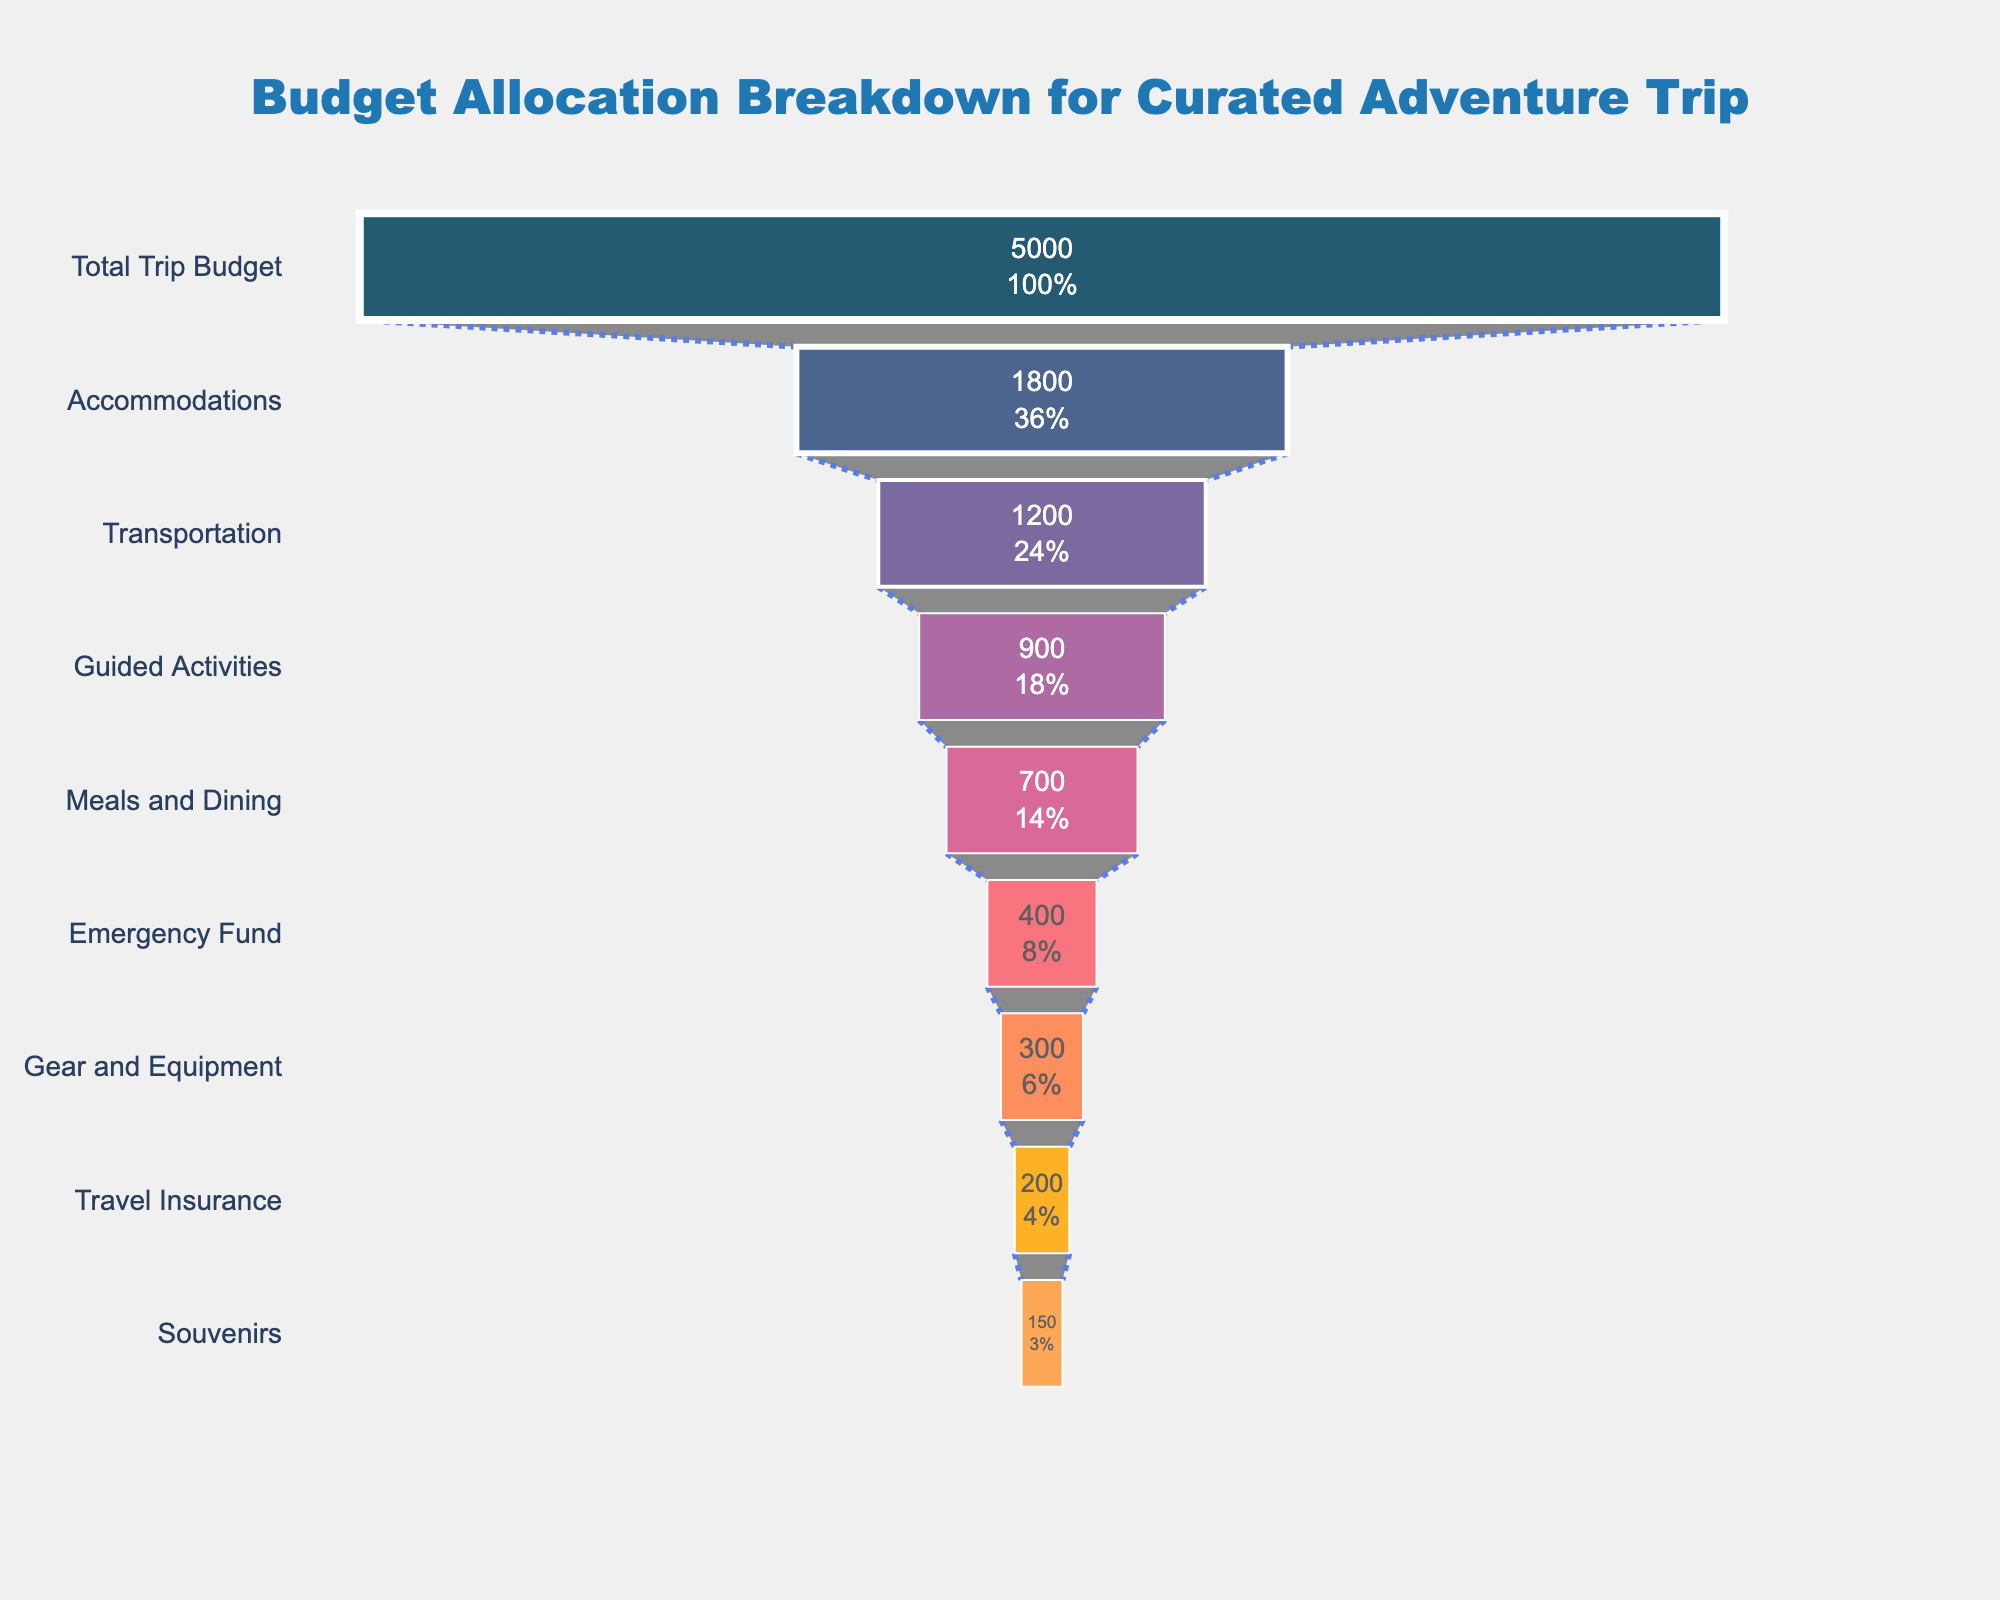What is the total budget for the trip as depicted in the figure? The total budget for the trip is the topmost stage in the funnel, labeled "Total Trip Budget," which shows an allocation of $5000.
Answer: $5000 Which aspect has the highest budget allocation after accommodations? The second highest budget allocation after accommodations is for transportation, as it is the next stage in the funnel with $1200 allocated.
Answer: Transportation How much more is allocated to accommodations compared to meals and dining? The amount allocated to accommodations is $1800 and meals and dining is $700. The difference is $1800 - $700 = $1100.
Answer: $1100 Which aspect has the lowest budget allocation? The lowest budget allocation is for souvenirs, as depicted at the bottom of the funnel with $150 allocated.
Answer: Souvenirs What percentage of the total budget is allocated to guided activities? Guided activities have a budget of $900. To find the percentage of the total budget, we use the formula (900 / 5000) * 100%, which equals 18%.
Answer: 18% Compare the combined budget of emergency fund and gear and equipment to the budget for accommodations. The emergency fund is $400 and gear and equipment is $300, combined they total $700. Accommodations have a budget of $1800, so $1800 - $700 = $1100 more for accommodations.
Answer: $1100 more for accommodations What is the proportion of the total budget allocated to travel insurance? Travel insurance has a budget of $200. To find the proportion, divide $200 by the total budget $5000, yielding 200/5000 = 0.04 or 4%.
Answer: 4% Which two aspects have nearly identical budget allocations, and what are their values? Gear and equipment and travel insurance have nearly identical budget allocations, with $300 and $200, respectively.
Answer: Gear and Equipment: $300, Travel Insurance: $200 What is the combined budget for accommodations, transportation, and guided activities? Adding the budgets for accommodations ($1800), transportation ($1200), and guided activities ($900), we get $1800 + $1200 + $900 = $3900.
Answer: $3900 Is the budget allocation for meals and dining more than or less than half of the budget for accommodations? The budget for meals and dining is $700, which is less than half of the budget for accommodations ($1800). Half of $1800 is $900, and $700 is less than $900.
Answer: Less than half 